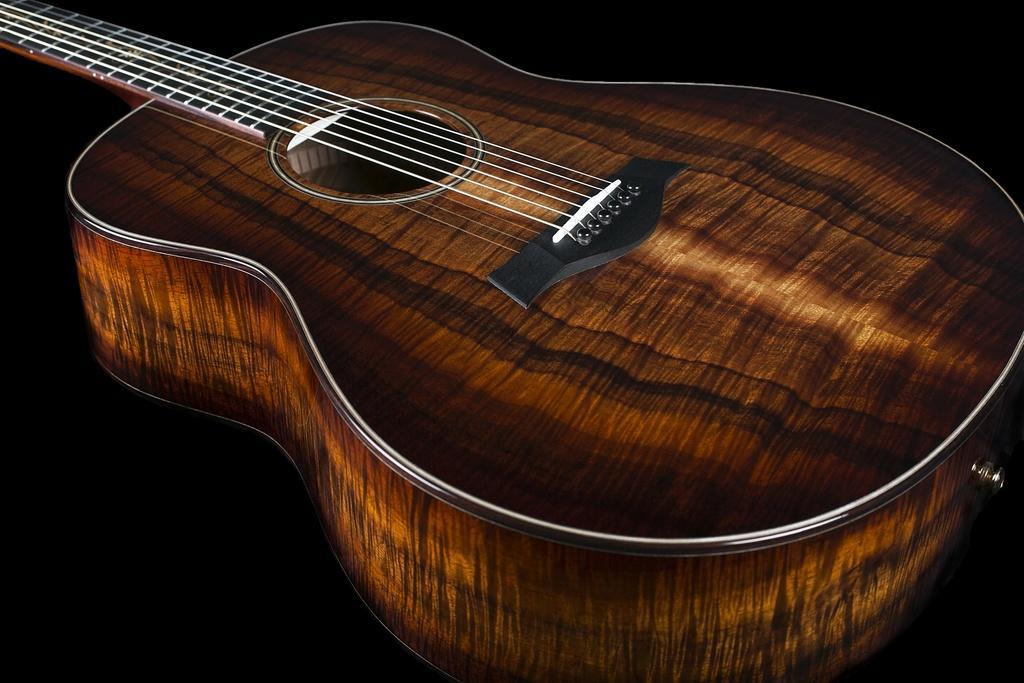In one or two sentences, can you explain what this image depicts? In this picture we can see a guitar present, it is made of wood and strings are white in color. 